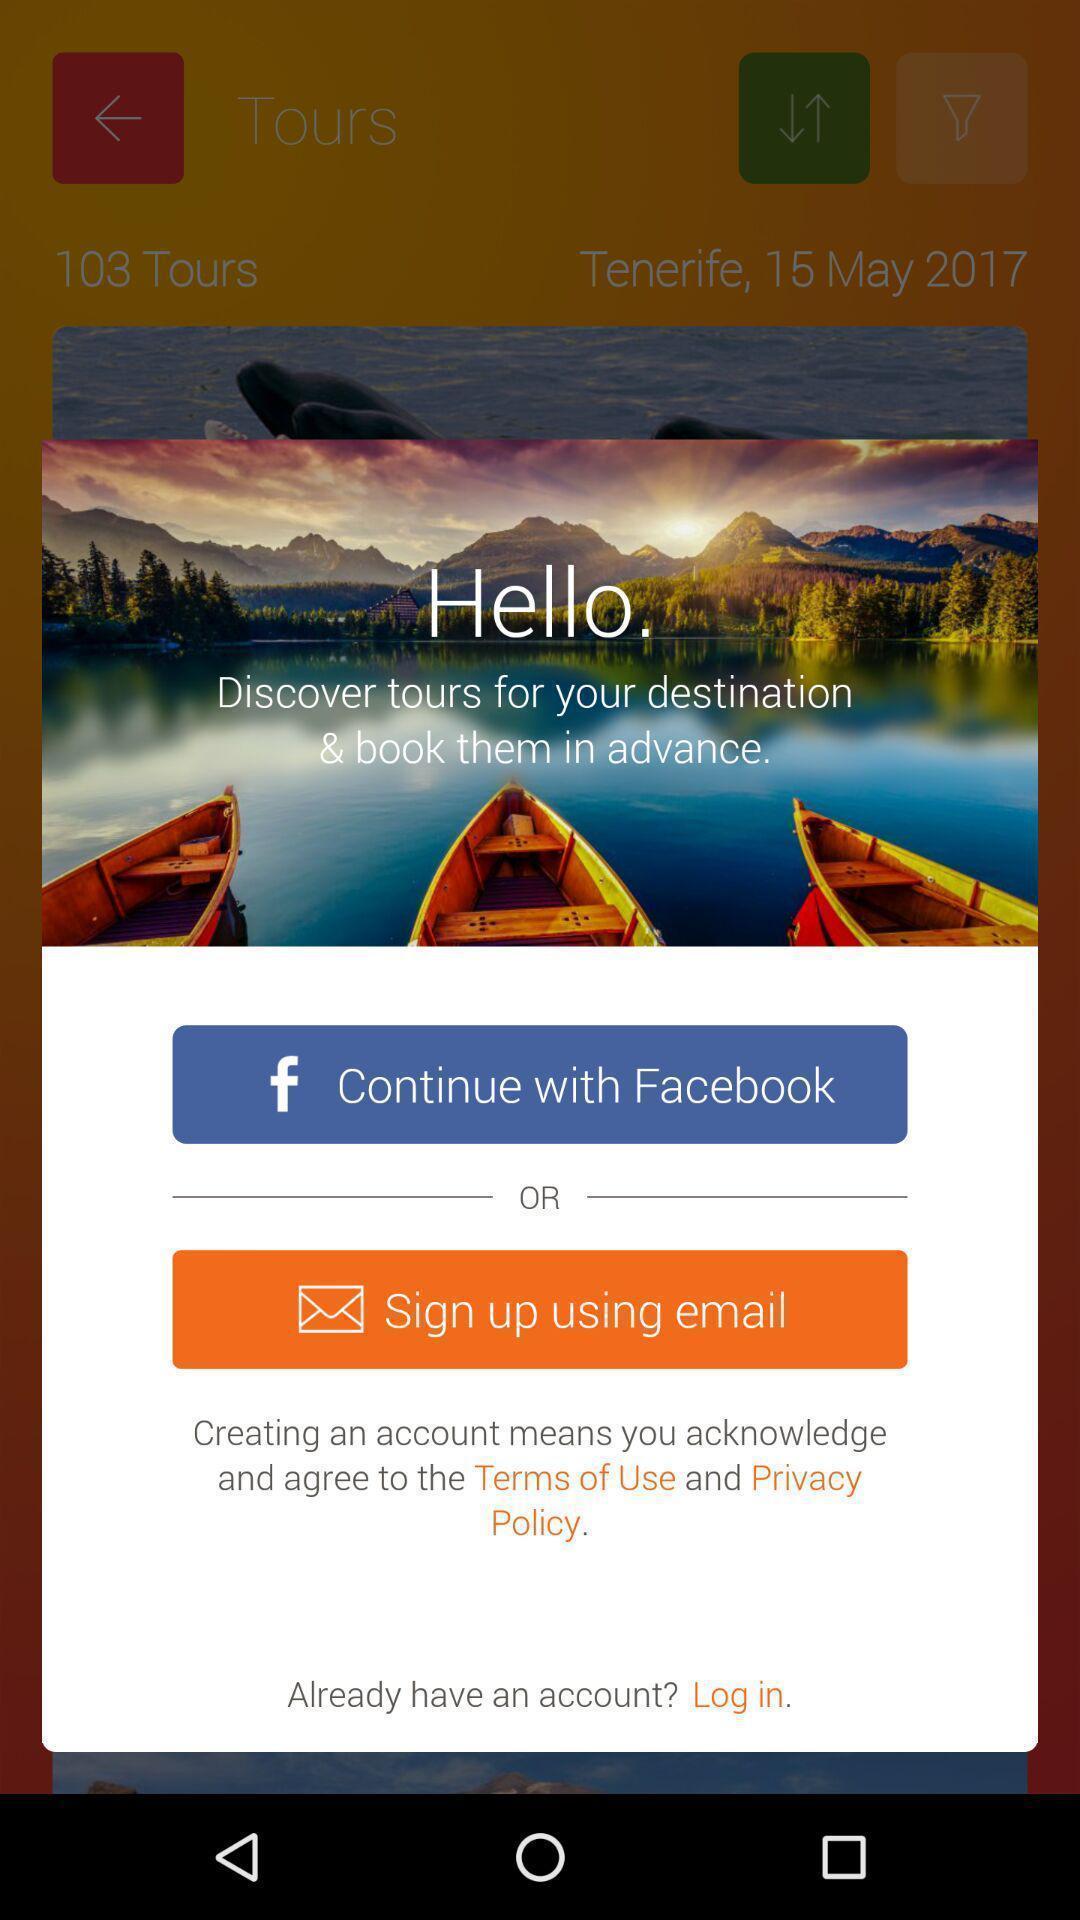Explain what's happening in this screen capture. Pop up sign up page displayed of travel bookings app. 